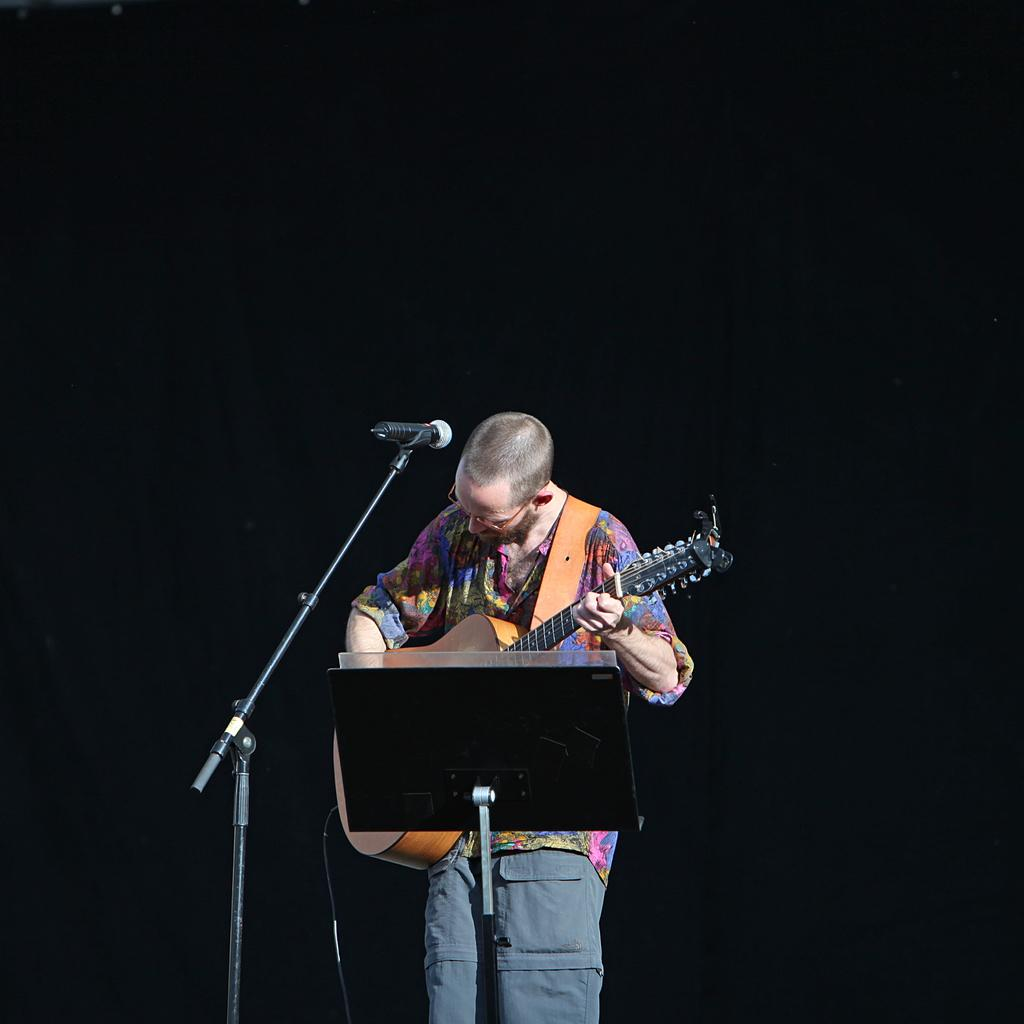What is the main subject of the image? There is a man in the image. What is the man doing in the image? The man is standing in the image. What object is the man holding in his hand? The man is holding a guitar in his hand. What equipment is set up in front of the man? There is a microphone with a stand in front of the man. Can you tell me how many times the man sneezes in the image? There is no indication of the man sneezing in the image; he is holding a guitar and standing near a microphone. 